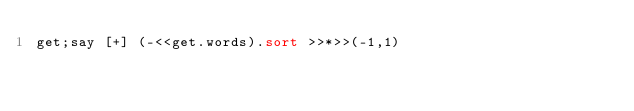Convert code to text. <code><loc_0><loc_0><loc_500><loc_500><_Perl_>get;say [+] (-<<get.words).sort >>*>>(-1,1)</code> 